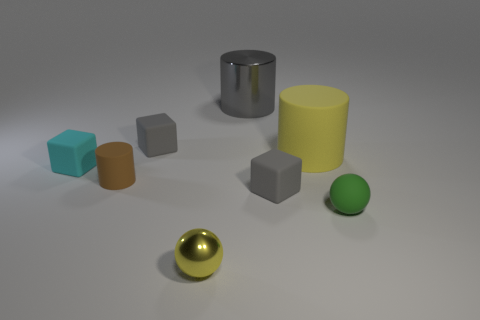The tiny shiny thing that is the same color as the large matte object is what shape?
Provide a succinct answer. Sphere. How big is the gray block to the left of the yellow thing in front of the tiny green object?
Keep it short and to the point. Small. There is a object that is behind the tiny cylinder and right of the big gray shiny cylinder; what material is it made of?
Your answer should be compact. Rubber. What number of other objects are there of the same size as the green ball?
Provide a short and direct response. 5. What is the color of the matte ball?
Provide a succinct answer. Green. There is a rubber cube that is in front of the brown object; is it the same color as the big matte object right of the large gray cylinder?
Make the answer very short. No. The gray metallic cylinder is what size?
Keep it short and to the point. Large. How big is the metal object in front of the gray shiny cylinder?
Your answer should be compact. Small. The tiny matte thing that is both on the left side of the yellow matte thing and in front of the tiny brown matte cylinder has what shape?
Offer a terse response. Cube. What number of other objects are there of the same shape as the big metal object?
Provide a succinct answer. 2. 